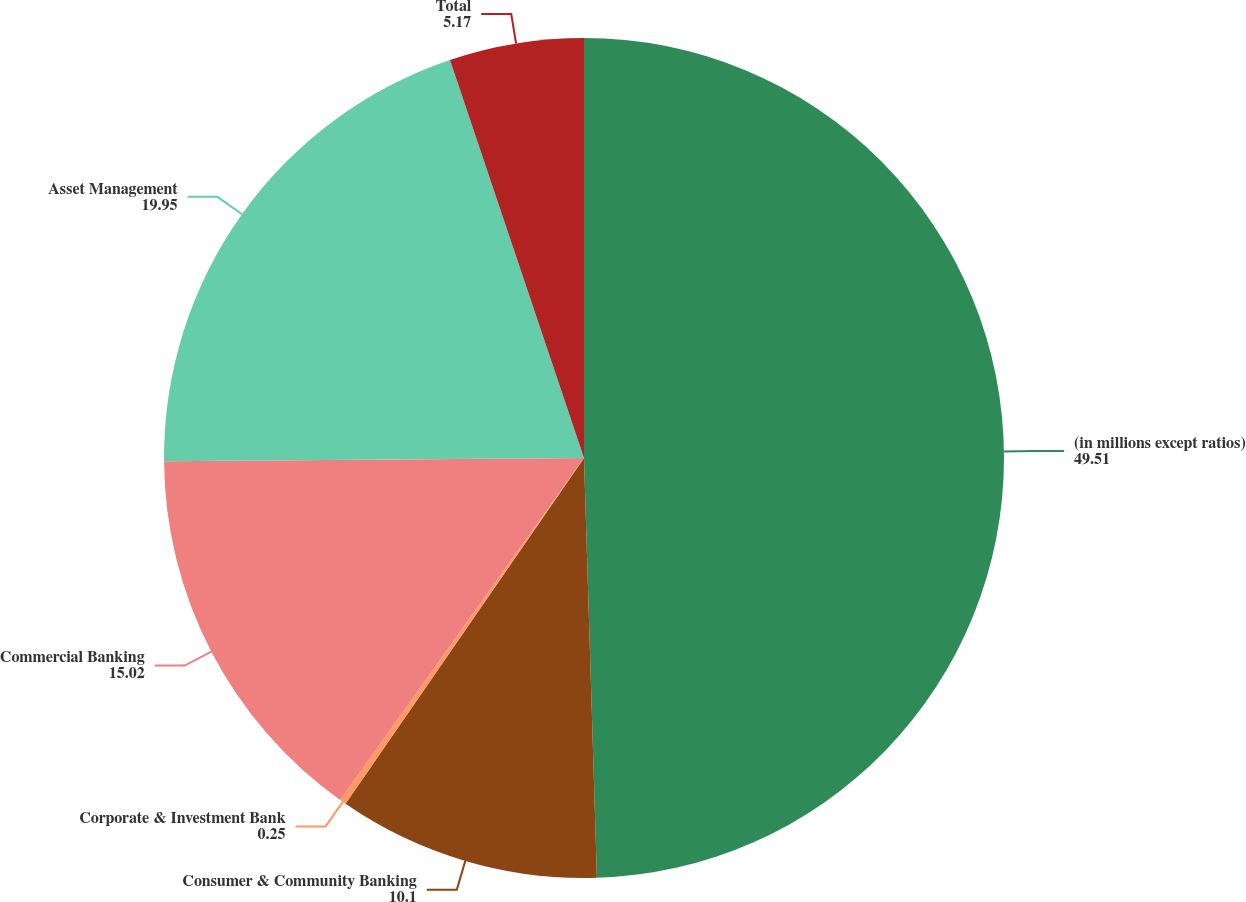Convert chart. <chart><loc_0><loc_0><loc_500><loc_500><pie_chart><fcel>(in millions except ratios)<fcel>Consumer & Community Banking<fcel>Corporate & Investment Bank<fcel>Commercial Banking<fcel>Asset Management<fcel>Total<nl><fcel>49.51%<fcel>10.1%<fcel>0.25%<fcel>15.02%<fcel>19.95%<fcel>5.17%<nl></chart> 